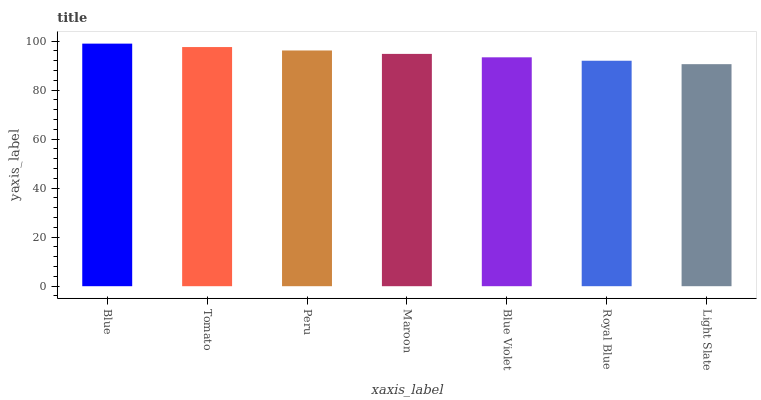Is Light Slate the minimum?
Answer yes or no. Yes. Is Blue the maximum?
Answer yes or no. Yes. Is Tomato the minimum?
Answer yes or no. No. Is Tomato the maximum?
Answer yes or no. No. Is Blue greater than Tomato?
Answer yes or no. Yes. Is Tomato less than Blue?
Answer yes or no. Yes. Is Tomato greater than Blue?
Answer yes or no. No. Is Blue less than Tomato?
Answer yes or no. No. Is Maroon the high median?
Answer yes or no. Yes. Is Maroon the low median?
Answer yes or no. Yes. Is Tomato the high median?
Answer yes or no. No. Is Blue the low median?
Answer yes or no. No. 